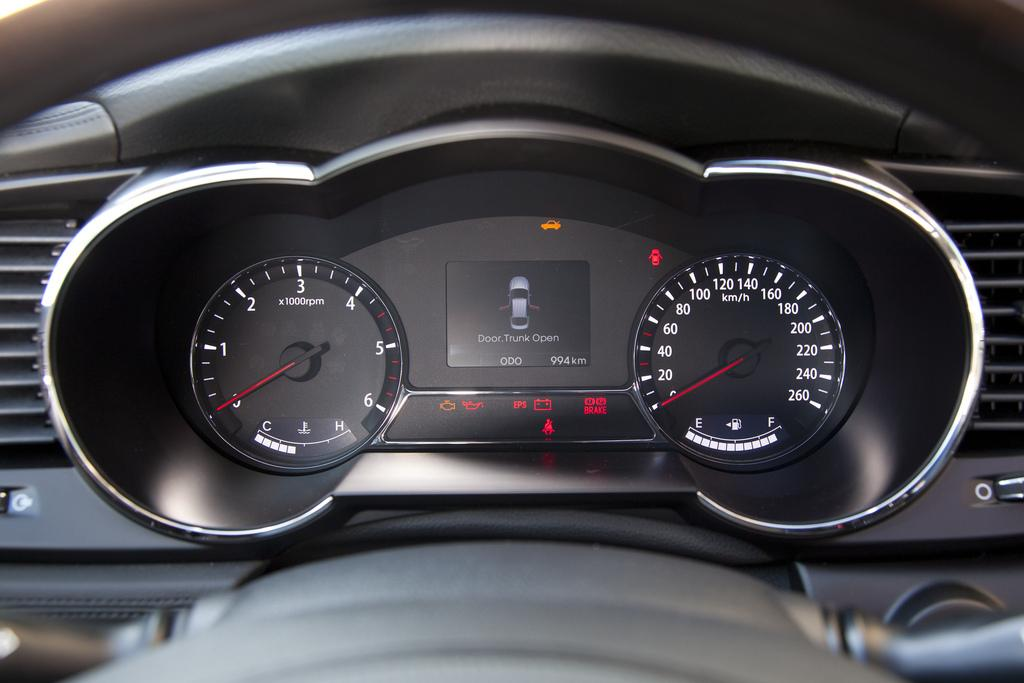What is the main subject of the image? The main subject of the image is a car. What can be seen inside the car in the image? There are gauges inside the car in the image. Is there any representation of a car on a screen in the image? Yes, there is a picture of a car on a screen in the image. What type of glove is being used to fix the car in the image? There is no glove present in the image, nor is there any indication of a car being fixed. 